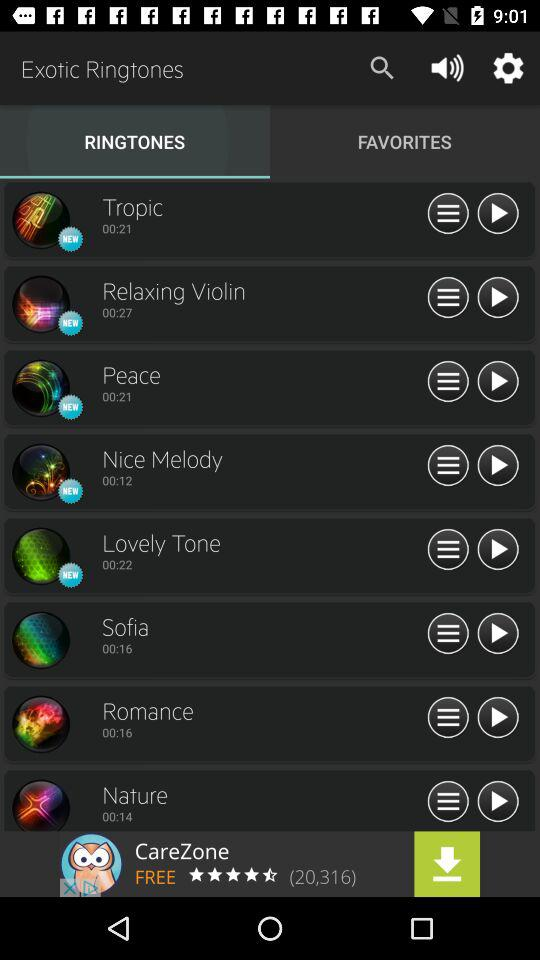What's the duration of the "Peace" ringtone? The duration is 00:21 seconds. 